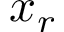Convert formula to latex. <formula><loc_0><loc_0><loc_500><loc_500>x _ { r }</formula> 